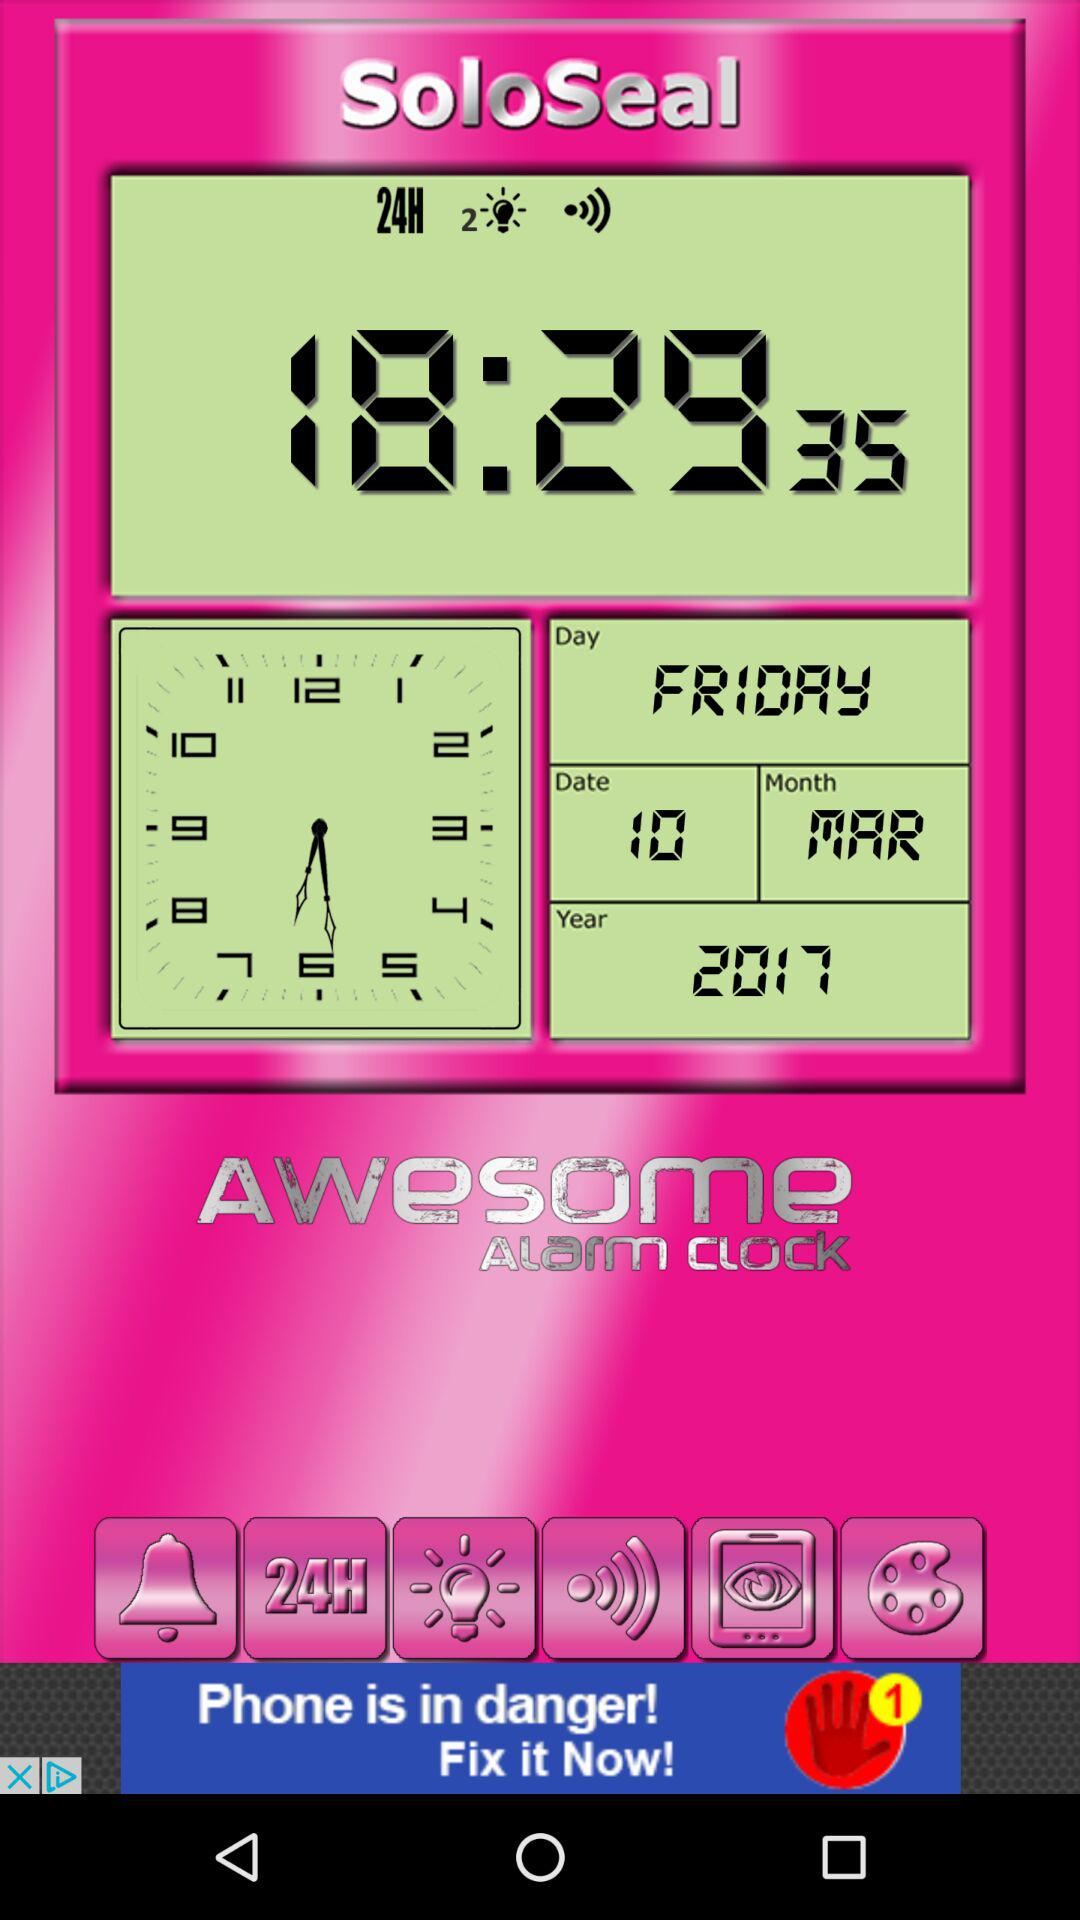What is the reflected month? The reflected month is March. 